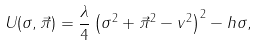Convert formula to latex. <formula><loc_0><loc_0><loc_500><loc_500>U ( \sigma , \vec { \pi } ) = \frac { \lambda } { 4 } \left ( \sigma ^ { 2 } + \vec { \pi } ^ { 2 } - v ^ { 2 } \right ) ^ { 2 } - h \sigma ,</formula> 